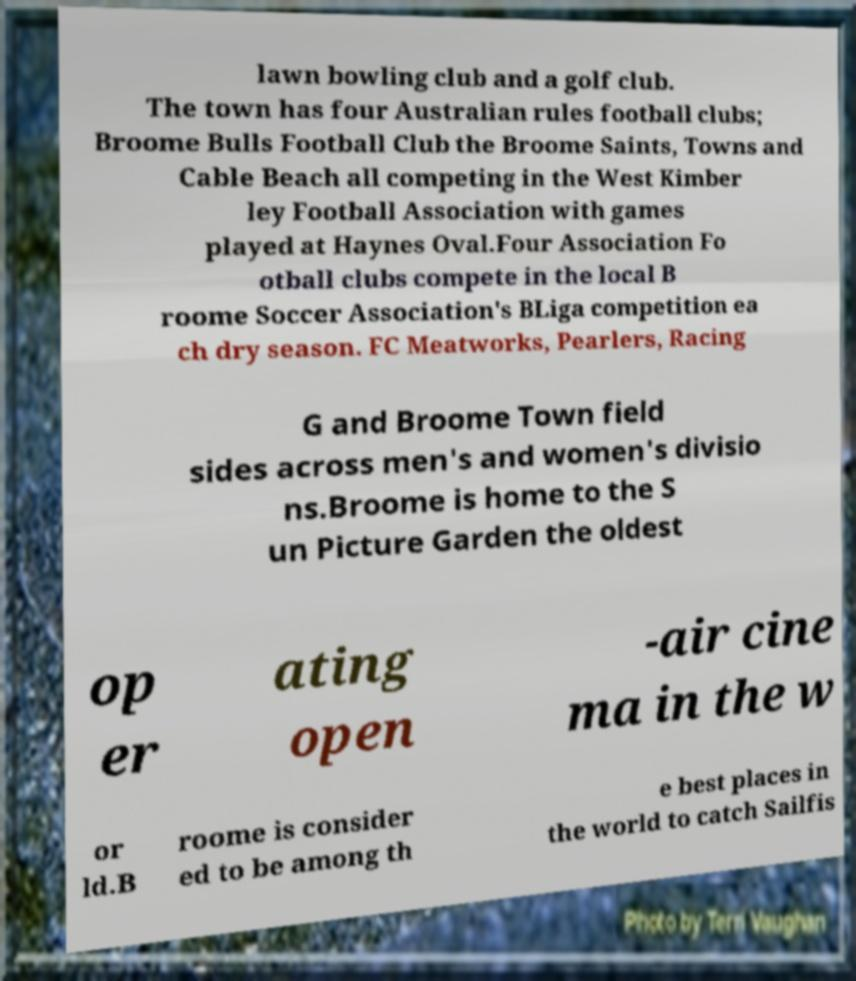Can you accurately transcribe the text from the provided image for me? lawn bowling club and a golf club. The town has four Australian rules football clubs; Broome Bulls Football Club the Broome Saints, Towns and Cable Beach all competing in the West Kimber ley Football Association with games played at Haynes Oval.Four Association Fo otball clubs compete in the local B roome Soccer Association's BLiga competition ea ch dry season. FC Meatworks, Pearlers, Racing G and Broome Town field sides across men's and women's divisio ns.Broome is home to the S un Picture Garden the oldest op er ating open -air cine ma in the w or ld.B roome is consider ed to be among th e best places in the world to catch Sailfis 